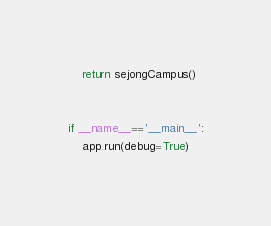<code> <loc_0><loc_0><loc_500><loc_500><_Python_>    return sejongCampus()


if __name__=='__main__':
    app.run(debug=True)
</code> 